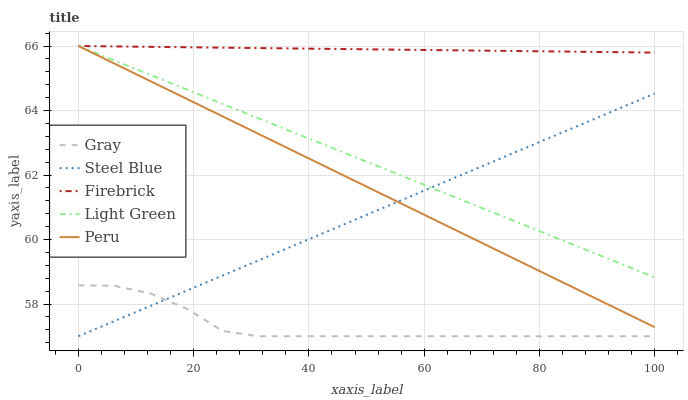Does Gray have the minimum area under the curve?
Answer yes or no. Yes. Does Firebrick have the maximum area under the curve?
Answer yes or no. Yes. Does Firebrick have the minimum area under the curve?
Answer yes or no. No. Does Gray have the maximum area under the curve?
Answer yes or no. No. Is Steel Blue the smoothest?
Answer yes or no. Yes. Is Gray the roughest?
Answer yes or no. Yes. Is Firebrick the smoothest?
Answer yes or no. No. Is Firebrick the roughest?
Answer yes or no. No. Does Gray have the lowest value?
Answer yes or no. Yes. Does Firebrick have the lowest value?
Answer yes or no. No. Does Light Green have the highest value?
Answer yes or no. Yes. Does Gray have the highest value?
Answer yes or no. No. Is Gray less than Peru?
Answer yes or no. Yes. Is Peru greater than Gray?
Answer yes or no. Yes. Does Peru intersect Firebrick?
Answer yes or no. Yes. Is Peru less than Firebrick?
Answer yes or no. No. Is Peru greater than Firebrick?
Answer yes or no. No. Does Gray intersect Peru?
Answer yes or no. No. 